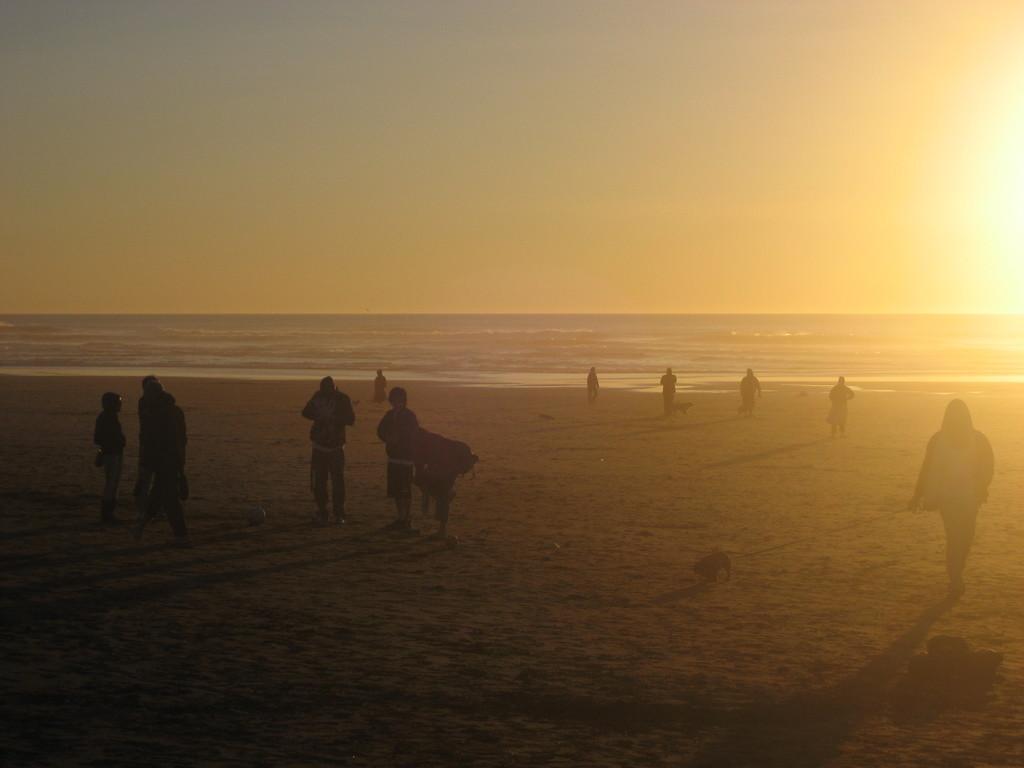Please provide a concise description of this image. In this picture there are persons standing and walking. In the background there is an ocean. 